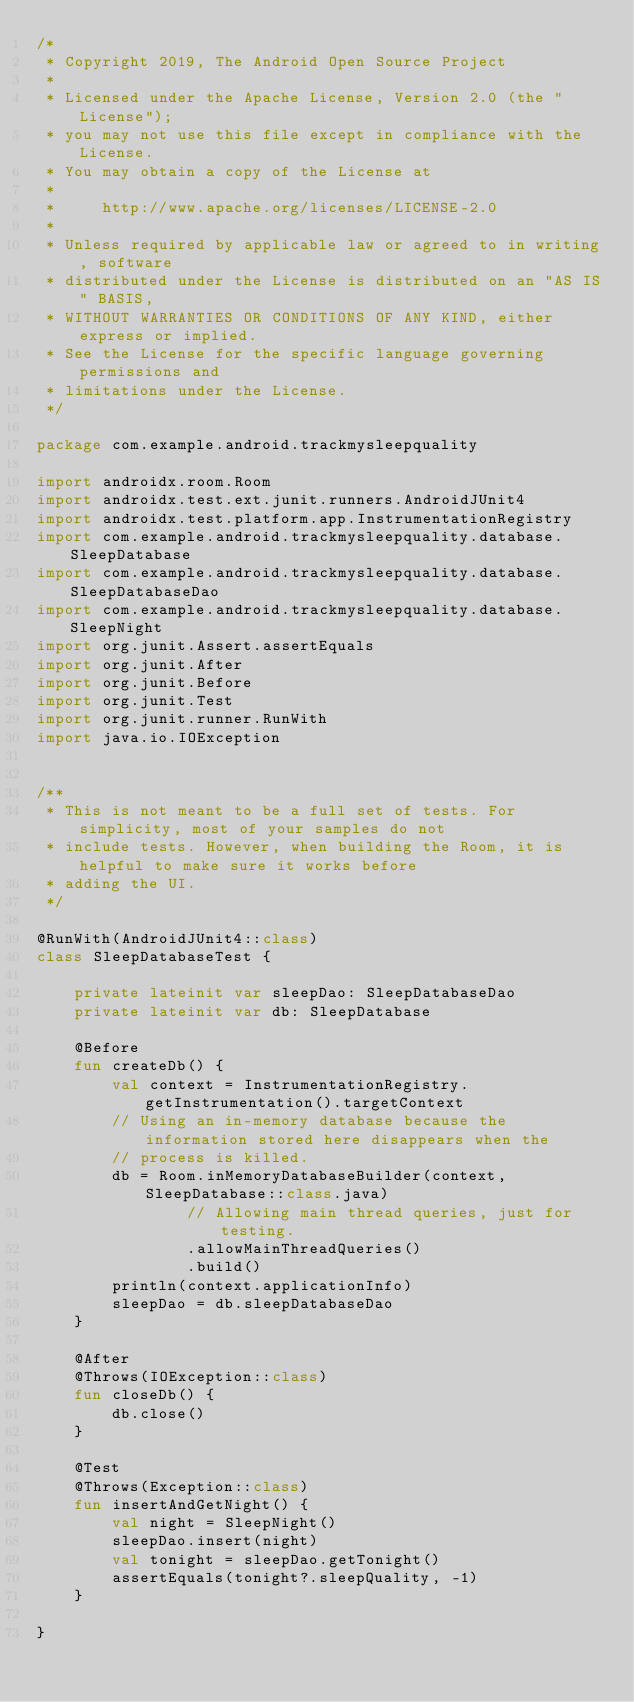<code> <loc_0><loc_0><loc_500><loc_500><_Kotlin_>/*
 * Copyright 2019, The Android Open Source Project
 *
 * Licensed under the Apache License, Version 2.0 (the "License");
 * you may not use this file except in compliance with the License.
 * You may obtain a copy of the License at
 *
 *     http://www.apache.org/licenses/LICENSE-2.0
 *
 * Unless required by applicable law or agreed to in writing, software
 * distributed under the License is distributed on an "AS IS" BASIS,
 * WITHOUT WARRANTIES OR CONDITIONS OF ANY KIND, either express or implied.
 * See the License for the specific language governing permissions and
 * limitations under the License.
 */

package com.example.android.trackmysleepquality

import androidx.room.Room
import androidx.test.ext.junit.runners.AndroidJUnit4
import androidx.test.platform.app.InstrumentationRegistry
import com.example.android.trackmysleepquality.database.SleepDatabase
import com.example.android.trackmysleepquality.database.SleepDatabaseDao
import com.example.android.trackmysleepquality.database.SleepNight
import org.junit.Assert.assertEquals
import org.junit.After
import org.junit.Before
import org.junit.Test
import org.junit.runner.RunWith
import java.io.IOException


/**
 * This is not meant to be a full set of tests. For simplicity, most of your samples do not
 * include tests. However, when building the Room, it is helpful to make sure it works before
 * adding the UI.
 */

@RunWith(AndroidJUnit4::class)
class SleepDatabaseTest {

    private lateinit var sleepDao: SleepDatabaseDao
    private lateinit var db: SleepDatabase

    @Before
    fun createDb() {
        val context = InstrumentationRegistry.getInstrumentation().targetContext
        // Using an in-memory database because the information stored here disappears when the
        // process is killed.
        db = Room.inMemoryDatabaseBuilder(context, SleepDatabase::class.java)
                // Allowing main thread queries, just for testing.
                .allowMainThreadQueries()
                .build()
        println(context.applicationInfo)
        sleepDao = db.sleepDatabaseDao
    }

    @After
    @Throws(IOException::class)
    fun closeDb() {
        db.close()
    }

    @Test
    @Throws(Exception::class)
    fun insertAndGetNight() {
        val night = SleepNight()
        sleepDao.insert(night)
        val tonight = sleepDao.getTonight()
        assertEquals(tonight?.sleepQuality, -1)
    }

}</code> 